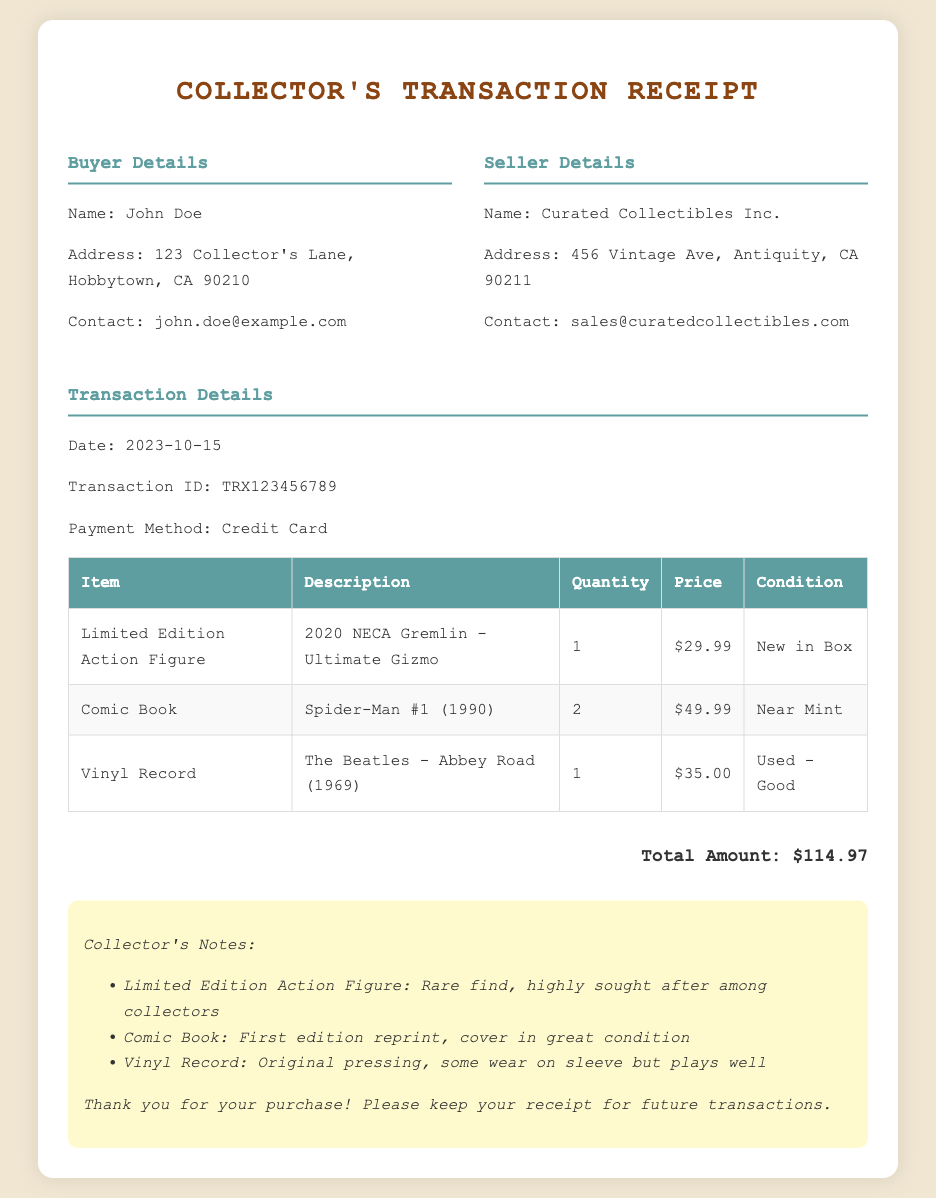what is the buyer's name? The buyer's name is specified in the document under Buyer Details as John Doe.
Answer: John Doe what is the transaction date? The transaction date is mentioned clearly in the Transaction Details section as 2023-10-15.
Answer: 2023-10-15 how many Spider-Man comics were purchased? The quantity of Spider-Man #1 comics is provided in the table under Quantity for that item, which states 2.
Answer: 2 what is the price of the Limited Edition Action Figure? The price for the Limited Edition Action Figure can be found in the table, listed as $29.99.
Answer: $29.99 what condition is the Vinyl Record in? The condition of the Vinyl Record is noted in the respective table row as Used - Good.
Answer: Used - Good what is the total amount of the transaction? The total amount is summarized at the end of the document and is calculated by adding all individual prices, which equals $114.97.
Answer: $114.97 who is the seller of the collectibles? The seller's name is given in the Seller Details section as Curated Collectibles Inc.
Answer: Curated Collectibles Inc how many items were purchased in total? The total number of items can be determined by adding the quantities listed in the table: 1 + 2 + 1 = 4.
Answer: 4 what is mentioned about the condition of the Comic Book? The Comic Book is described in the document as Near Mint in the table under Condition.
Answer: Near Mint 